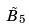<formula> <loc_0><loc_0><loc_500><loc_500>\tilde { B } _ { 5 }</formula> 